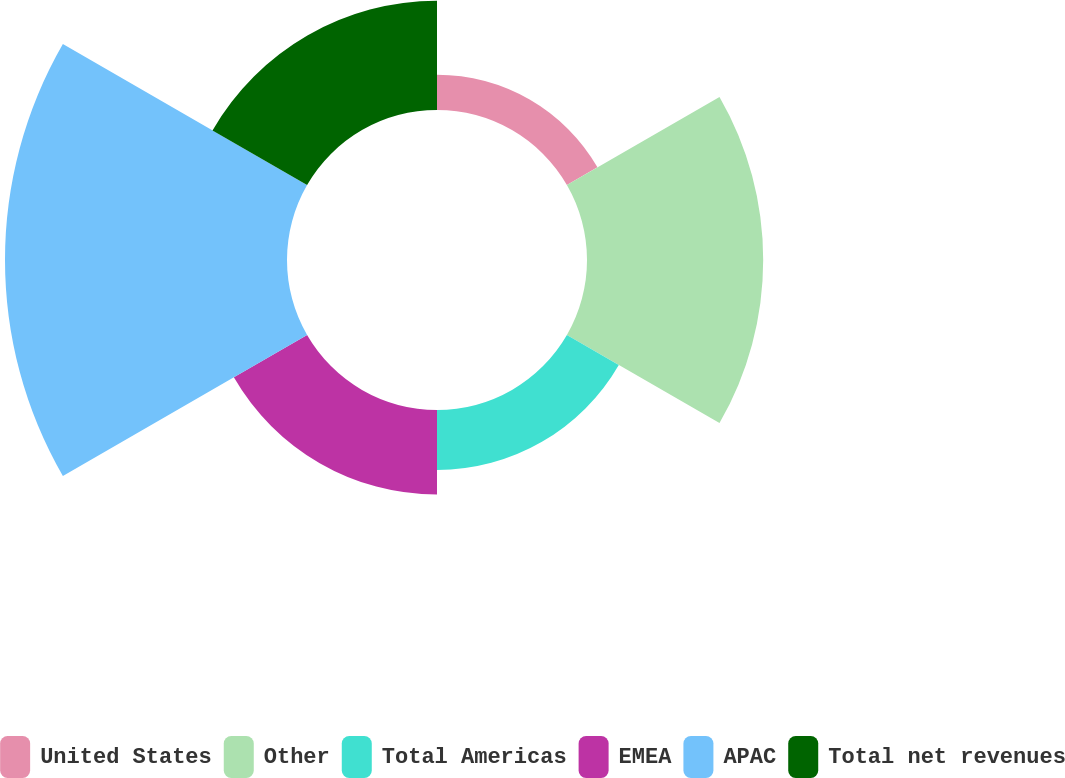Convert chart to OTSL. <chart><loc_0><loc_0><loc_500><loc_500><pie_chart><fcel>United States<fcel>Other<fcel>Total Americas<fcel>EMEA<fcel>APAC<fcel>Total net revenues<nl><fcel>4.72%<fcel>23.58%<fcel>8.02%<fcel>11.32%<fcel>37.74%<fcel>14.62%<nl></chart> 